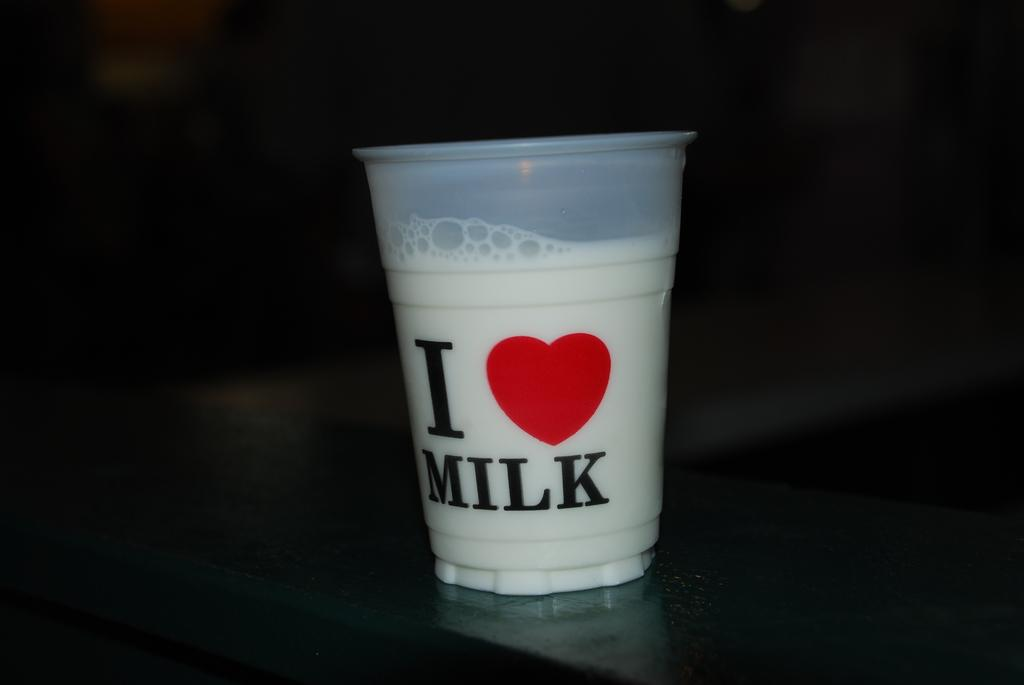Provide a one-sentence caption for the provided image. A glass of milk that says I love milk on a dark table. 